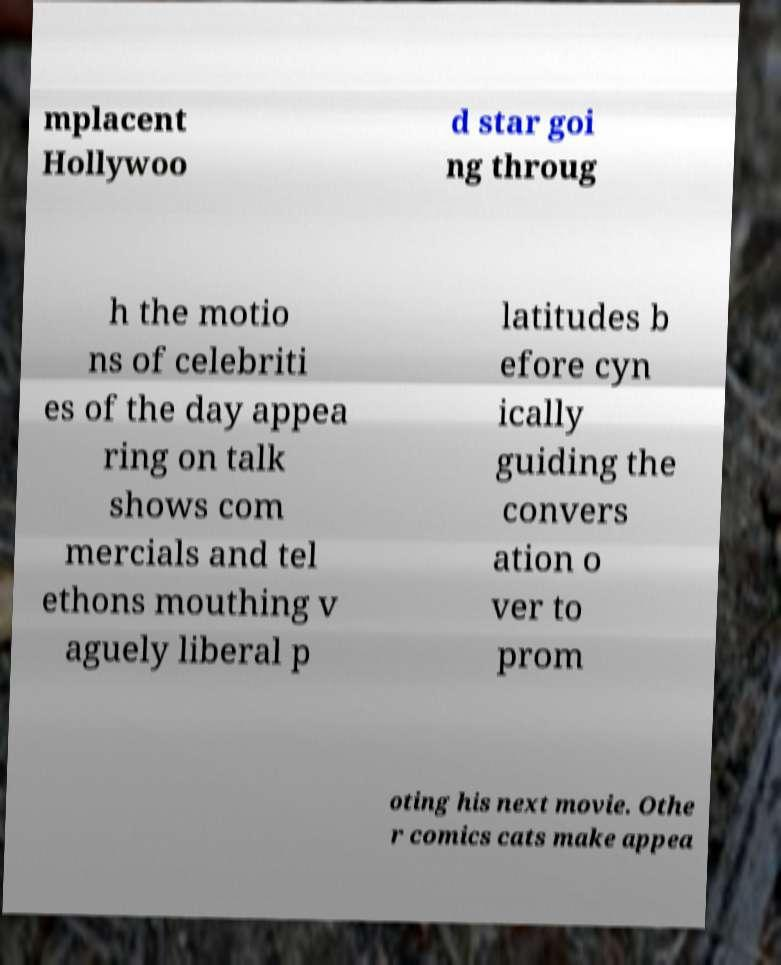For documentation purposes, I need the text within this image transcribed. Could you provide that? mplacent Hollywoo d star goi ng throug h the motio ns of celebriti es of the day appea ring on talk shows com mercials and tel ethons mouthing v aguely liberal p latitudes b efore cyn ically guiding the convers ation o ver to prom oting his next movie. Othe r comics cats make appea 